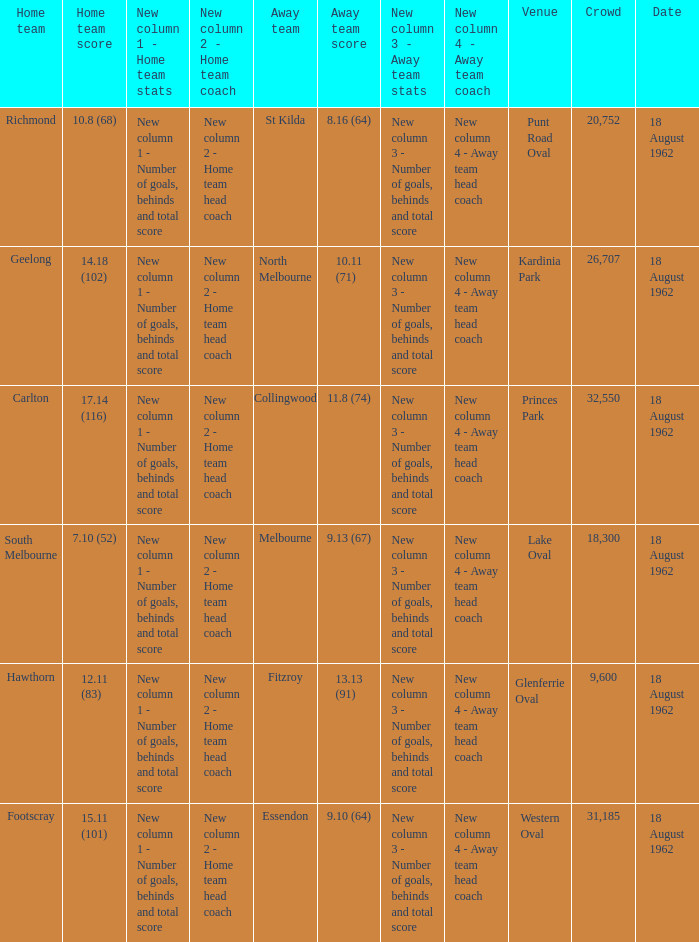What was the home team that scored 10.8 (68)? Richmond. 